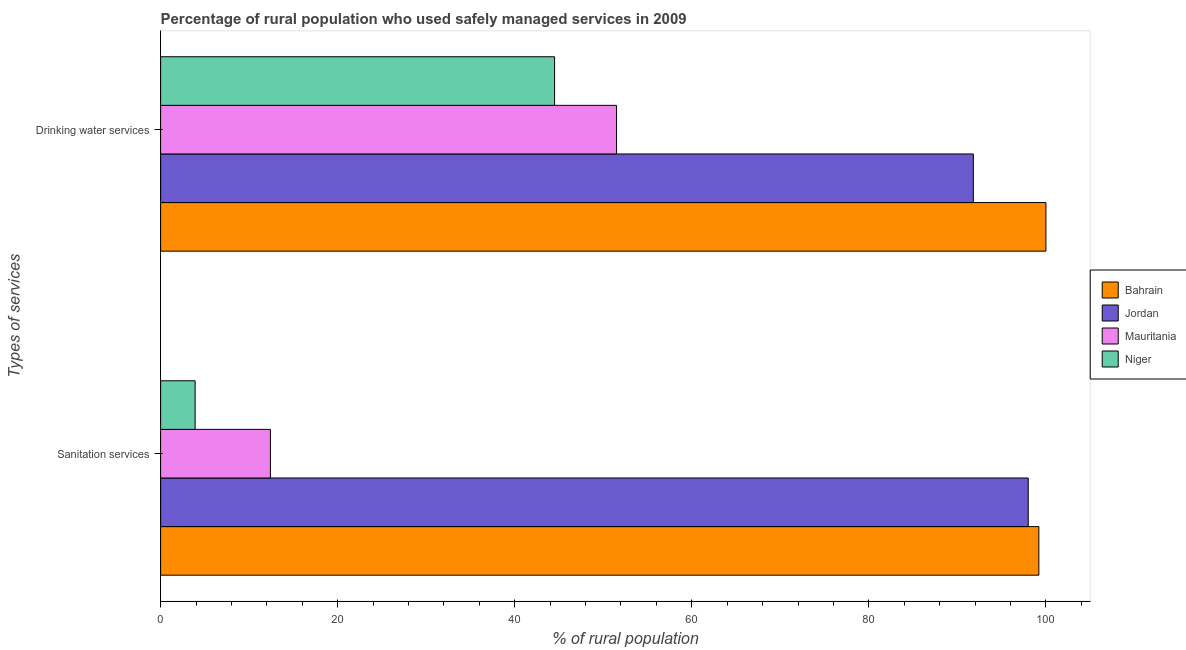How many groups of bars are there?
Offer a very short reply. 2. Are the number of bars per tick equal to the number of legend labels?
Your answer should be compact. Yes. How many bars are there on the 1st tick from the top?
Offer a very short reply. 4. What is the label of the 2nd group of bars from the top?
Ensure brevity in your answer.  Sanitation services. Across all countries, what is the minimum percentage of rural population who used sanitation services?
Keep it short and to the point. 3.9. In which country was the percentage of rural population who used drinking water services maximum?
Ensure brevity in your answer.  Bahrain. In which country was the percentage of rural population who used drinking water services minimum?
Make the answer very short. Niger. What is the total percentage of rural population who used drinking water services in the graph?
Your answer should be compact. 287.8. What is the difference between the percentage of rural population who used sanitation services in Jordan and that in Bahrain?
Your answer should be very brief. -1.2. What is the difference between the percentage of rural population who used drinking water services in Mauritania and the percentage of rural population who used sanitation services in Niger?
Keep it short and to the point. 47.6. What is the average percentage of rural population who used sanitation services per country?
Keep it short and to the point. 53.38. What is the difference between the percentage of rural population who used drinking water services and percentage of rural population who used sanitation services in Mauritania?
Your answer should be very brief. 39.1. What is the ratio of the percentage of rural population who used drinking water services in Niger to that in Mauritania?
Ensure brevity in your answer.  0.86. Is the percentage of rural population who used drinking water services in Niger less than that in Mauritania?
Your response must be concise. Yes. What does the 1st bar from the top in Sanitation services represents?
Your response must be concise. Niger. What does the 2nd bar from the bottom in Sanitation services represents?
Offer a very short reply. Jordan. Are all the bars in the graph horizontal?
Provide a short and direct response. Yes. How many countries are there in the graph?
Keep it short and to the point. 4. What is the difference between two consecutive major ticks on the X-axis?
Provide a short and direct response. 20. Does the graph contain any zero values?
Keep it short and to the point. No. Does the graph contain grids?
Ensure brevity in your answer.  No. Where does the legend appear in the graph?
Your answer should be compact. Center right. How many legend labels are there?
Your answer should be compact. 4. How are the legend labels stacked?
Offer a very short reply. Vertical. What is the title of the graph?
Ensure brevity in your answer.  Percentage of rural population who used safely managed services in 2009. Does "Other small states" appear as one of the legend labels in the graph?
Your answer should be very brief. No. What is the label or title of the X-axis?
Offer a very short reply. % of rural population. What is the label or title of the Y-axis?
Your answer should be very brief. Types of services. What is the % of rural population in Bahrain in Sanitation services?
Ensure brevity in your answer.  99.2. What is the % of rural population of Jordan in Sanitation services?
Provide a succinct answer. 98. What is the % of rural population of Niger in Sanitation services?
Offer a very short reply. 3.9. What is the % of rural population in Bahrain in Drinking water services?
Make the answer very short. 100. What is the % of rural population of Jordan in Drinking water services?
Give a very brief answer. 91.8. What is the % of rural population of Mauritania in Drinking water services?
Give a very brief answer. 51.5. What is the % of rural population of Niger in Drinking water services?
Offer a terse response. 44.5. Across all Types of services, what is the maximum % of rural population of Jordan?
Your response must be concise. 98. Across all Types of services, what is the maximum % of rural population of Mauritania?
Your answer should be very brief. 51.5. Across all Types of services, what is the maximum % of rural population of Niger?
Your answer should be compact. 44.5. Across all Types of services, what is the minimum % of rural population in Bahrain?
Keep it short and to the point. 99.2. Across all Types of services, what is the minimum % of rural population in Jordan?
Offer a terse response. 91.8. Across all Types of services, what is the minimum % of rural population in Mauritania?
Keep it short and to the point. 12.4. What is the total % of rural population in Bahrain in the graph?
Your answer should be very brief. 199.2. What is the total % of rural population in Jordan in the graph?
Provide a succinct answer. 189.8. What is the total % of rural population in Mauritania in the graph?
Your response must be concise. 63.9. What is the total % of rural population in Niger in the graph?
Your answer should be very brief. 48.4. What is the difference between the % of rural population in Bahrain in Sanitation services and that in Drinking water services?
Your answer should be compact. -0.8. What is the difference between the % of rural population of Jordan in Sanitation services and that in Drinking water services?
Provide a short and direct response. 6.2. What is the difference between the % of rural population of Mauritania in Sanitation services and that in Drinking water services?
Ensure brevity in your answer.  -39.1. What is the difference between the % of rural population in Niger in Sanitation services and that in Drinking water services?
Your answer should be compact. -40.6. What is the difference between the % of rural population in Bahrain in Sanitation services and the % of rural population in Jordan in Drinking water services?
Offer a terse response. 7.4. What is the difference between the % of rural population of Bahrain in Sanitation services and the % of rural population of Mauritania in Drinking water services?
Make the answer very short. 47.7. What is the difference between the % of rural population in Bahrain in Sanitation services and the % of rural population in Niger in Drinking water services?
Provide a succinct answer. 54.7. What is the difference between the % of rural population in Jordan in Sanitation services and the % of rural population in Mauritania in Drinking water services?
Your response must be concise. 46.5. What is the difference between the % of rural population in Jordan in Sanitation services and the % of rural population in Niger in Drinking water services?
Offer a terse response. 53.5. What is the difference between the % of rural population in Mauritania in Sanitation services and the % of rural population in Niger in Drinking water services?
Your answer should be compact. -32.1. What is the average % of rural population of Bahrain per Types of services?
Your answer should be compact. 99.6. What is the average % of rural population in Jordan per Types of services?
Your answer should be compact. 94.9. What is the average % of rural population of Mauritania per Types of services?
Your response must be concise. 31.95. What is the average % of rural population in Niger per Types of services?
Your answer should be compact. 24.2. What is the difference between the % of rural population in Bahrain and % of rural population in Jordan in Sanitation services?
Keep it short and to the point. 1.2. What is the difference between the % of rural population in Bahrain and % of rural population in Mauritania in Sanitation services?
Offer a very short reply. 86.8. What is the difference between the % of rural population of Bahrain and % of rural population of Niger in Sanitation services?
Provide a short and direct response. 95.3. What is the difference between the % of rural population of Jordan and % of rural population of Mauritania in Sanitation services?
Provide a succinct answer. 85.6. What is the difference between the % of rural population of Jordan and % of rural population of Niger in Sanitation services?
Ensure brevity in your answer.  94.1. What is the difference between the % of rural population in Bahrain and % of rural population in Jordan in Drinking water services?
Keep it short and to the point. 8.2. What is the difference between the % of rural population in Bahrain and % of rural population in Mauritania in Drinking water services?
Give a very brief answer. 48.5. What is the difference between the % of rural population of Bahrain and % of rural population of Niger in Drinking water services?
Your answer should be compact. 55.5. What is the difference between the % of rural population in Jordan and % of rural population in Mauritania in Drinking water services?
Offer a terse response. 40.3. What is the difference between the % of rural population of Jordan and % of rural population of Niger in Drinking water services?
Your answer should be very brief. 47.3. What is the difference between the % of rural population of Mauritania and % of rural population of Niger in Drinking water services?
Provide a succinct answer. 7. What is the ratio of the % of rural population of Jordan in Sanitation services to that in Drinking water services?
Offer a very short reply. 1.07. What is the ratio of the % of rural population in Mauritania in Sanitation services to that in Drinking water services?
Offer a very short reply. 0.24. What is the ratio of the % of rural population of Niger in Sanitation services to that in Drinking water services?
Ensure brevity in your answer.  0.09. What is the difference between the highest and the second highest % of rural population in Mauritania?
Your answer should be very brief. 39.1. What is the difference between the highest and the second highest % of rural population of Niger?
Keep it short and to the point. 40.6. What is the difference between the highest and the lowest % of rural population in Bahrain?
Provide a succinct answer. 0.8. What is the difference between the highest and the lowest % of rural population in Mauritania?
Give a very brief answer. 39.1. What is the difference between the highest and the lowest % of rural population in Niger?
Your answer should be very brief. 40.6. 